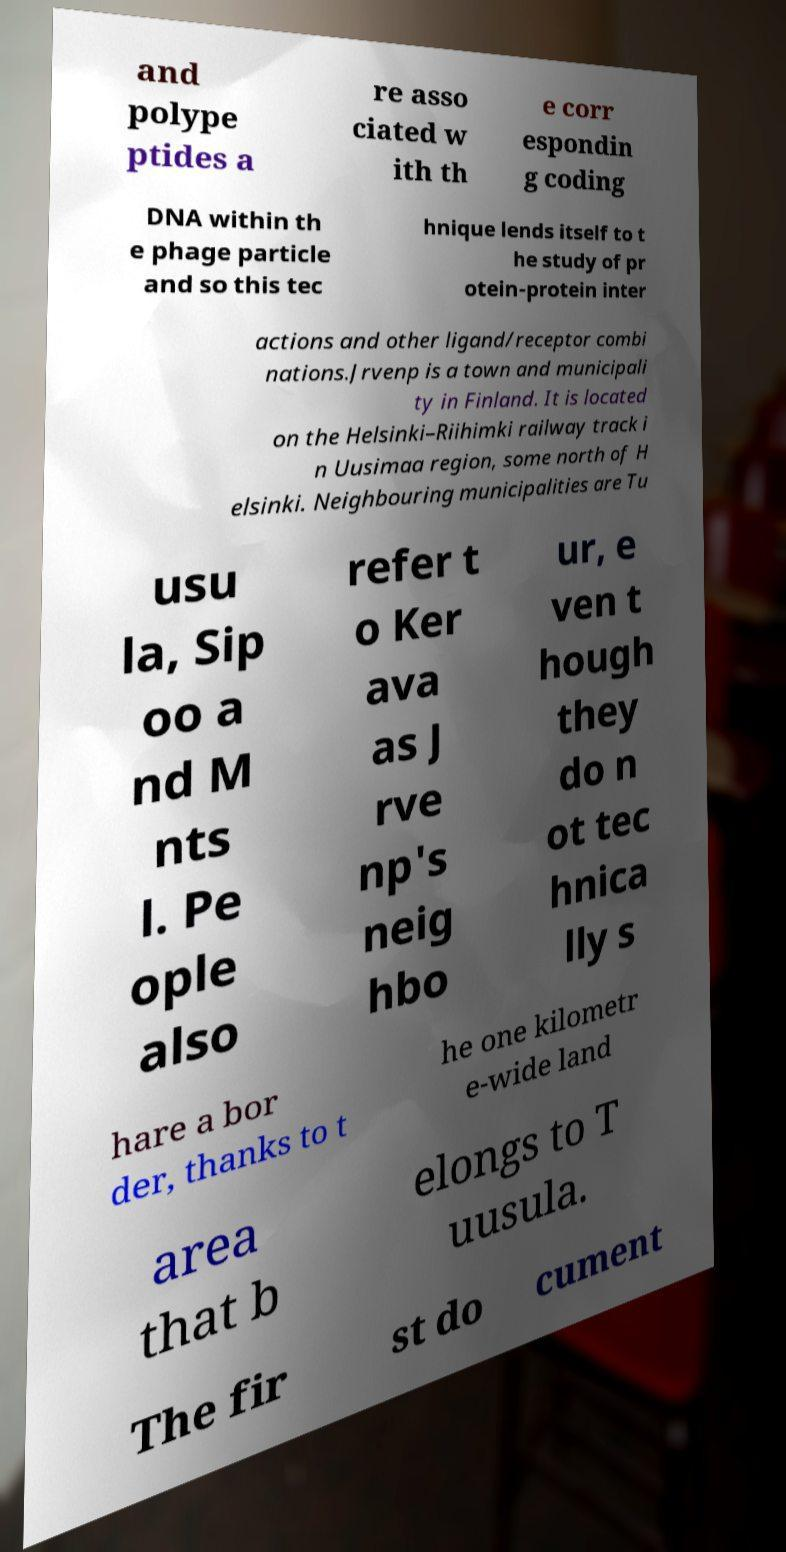I need the written content from this picture converted into text. Can you do that? and polype ptides a re asso ciated w ith th e corr espondin g coding DNA within th e phage particle and so this tec hnique lends itself to t he study of pr otein-protein inter actions and other ligand/receptor combi nations.Jrvenp is a town and municipali ty in Finland. It is located on the Helsinki–Riihimki railway track i n Uusimaa region, some north of H elsinki. Neighbouring municipalities are Tu usu la, Sip oo a nd M nts l. Pe ople also refer t o Ker ava as J rve np's neig hbo ur, e ven t hough they do n ot tec hnica lly s hare a bor der, thanks to t he one kilometr e-wide land area that b elongs to T uusula. The fir st do cument 